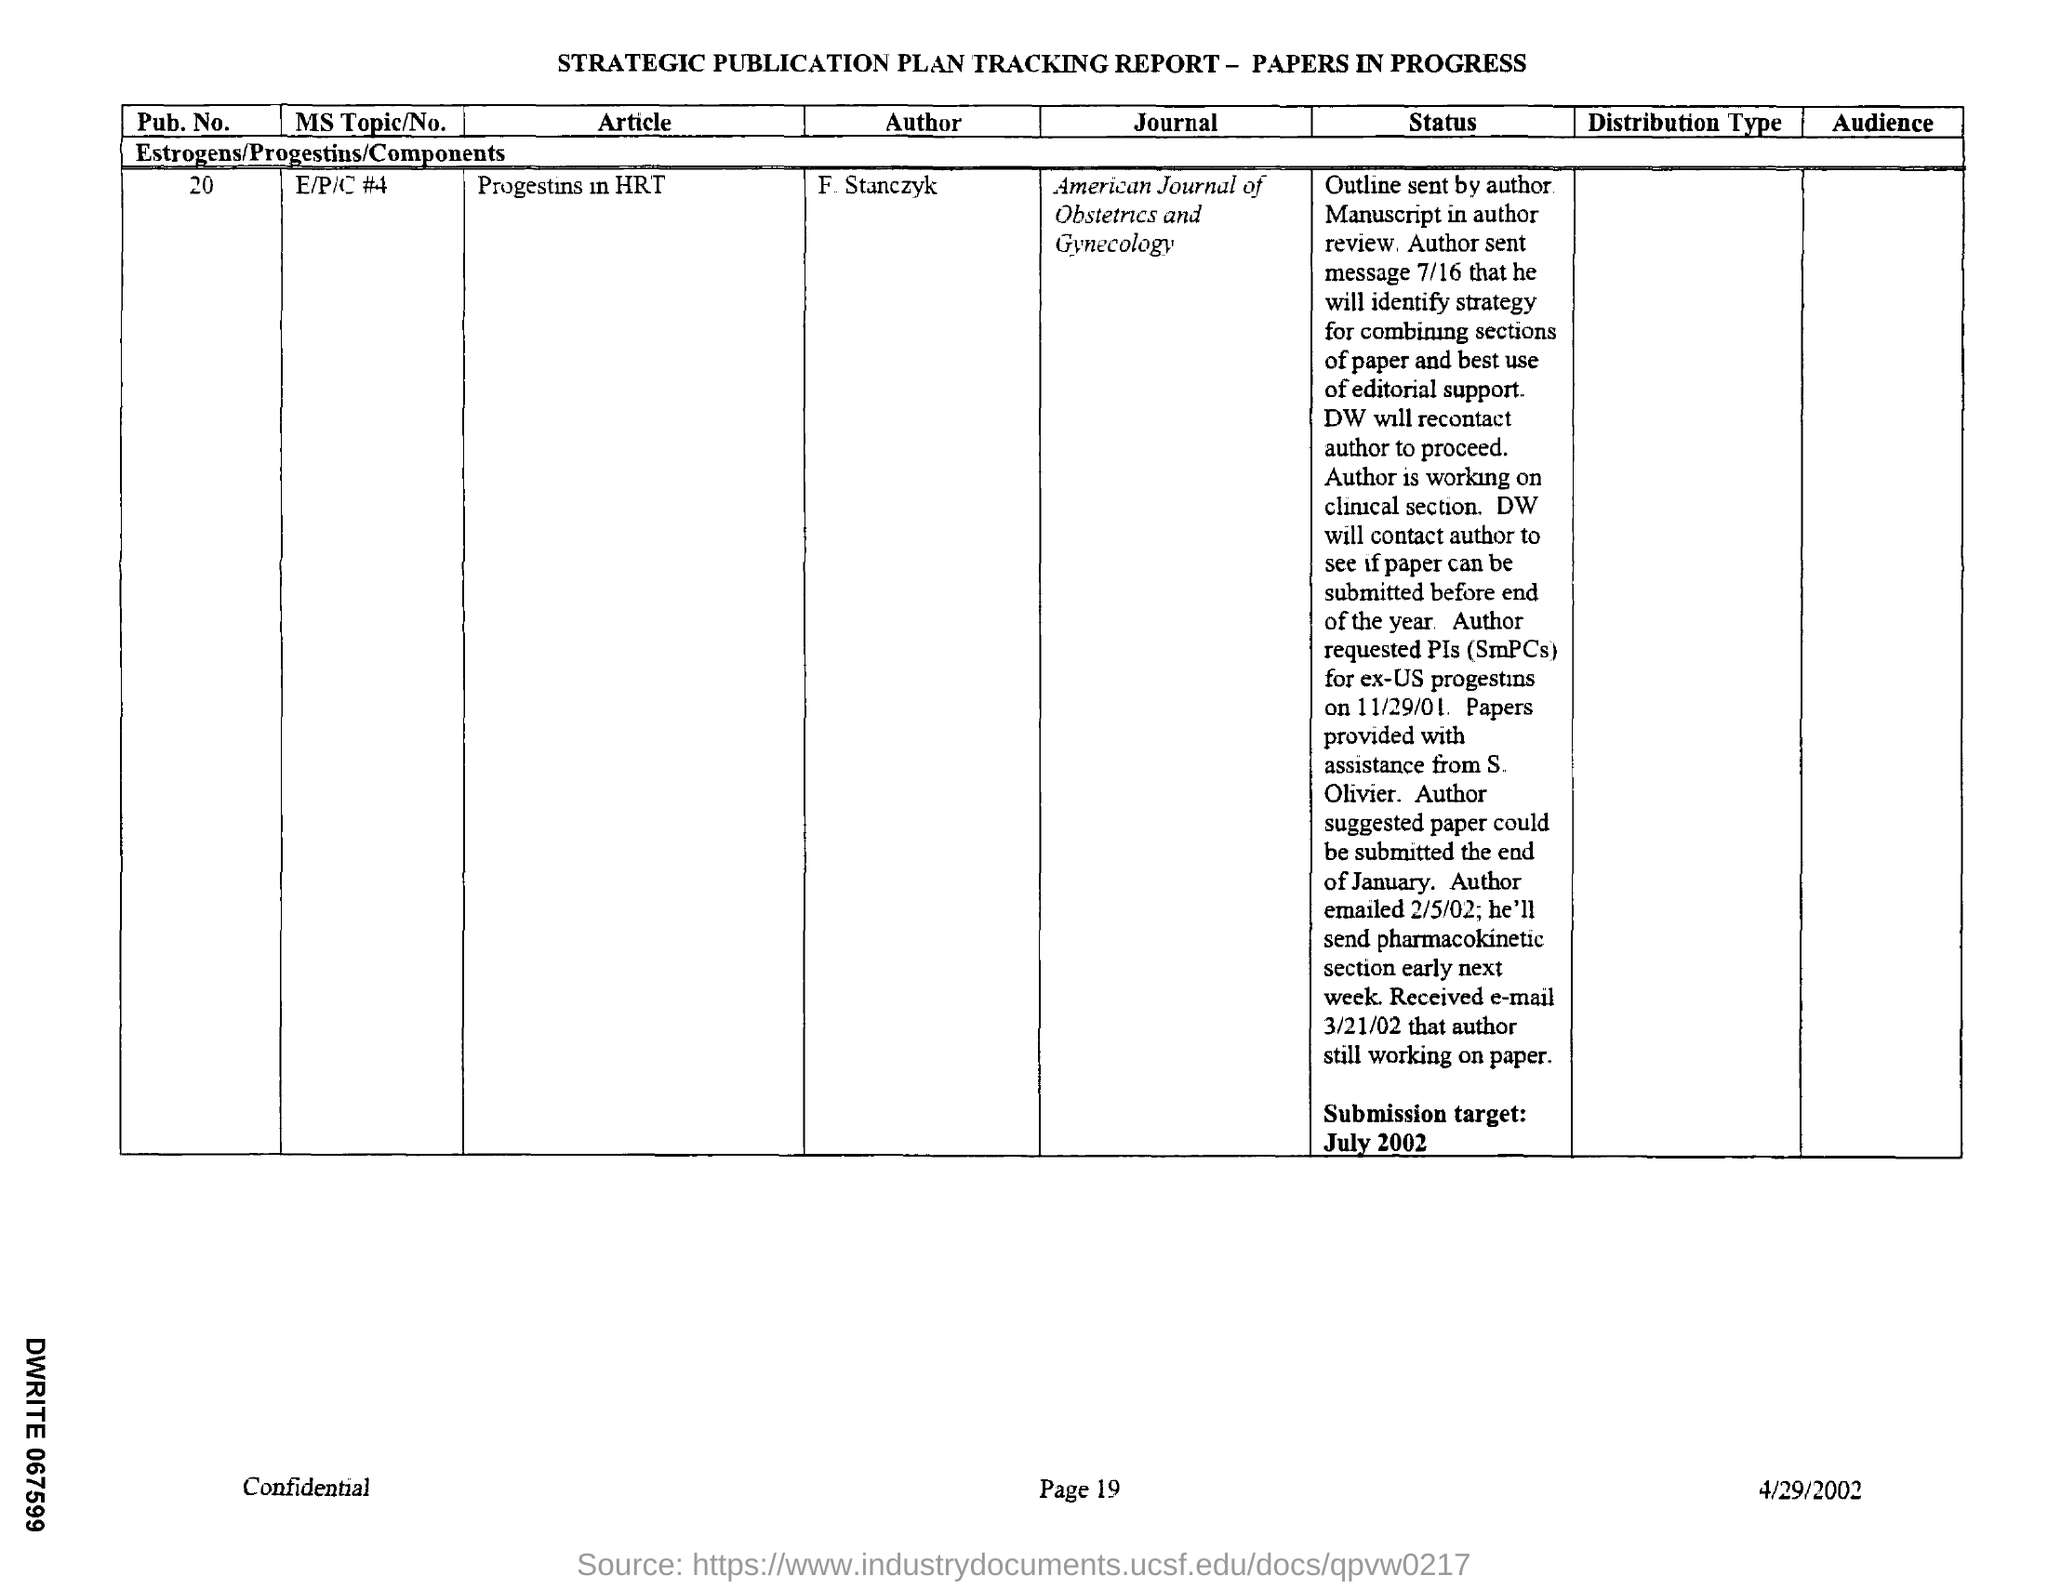What is the name of the article mentioned in the given report ?
Make the answer very short. Progestins in HRT. What is the name of the author mentioned in the given tracking report ?
Provide a succinct answer. F  Stanczyk. What is the journal mentioned in the tracking report ?
Offer a very short reply. American Journal of Obstetrics and Gynecology. What is the pub .no. mentioned in the given tracking report ?
Your answer should be compact. 20. What is ms topic/no mentioned in the given report ?
Ensure brevity in your answer.  E/P/C #4. 